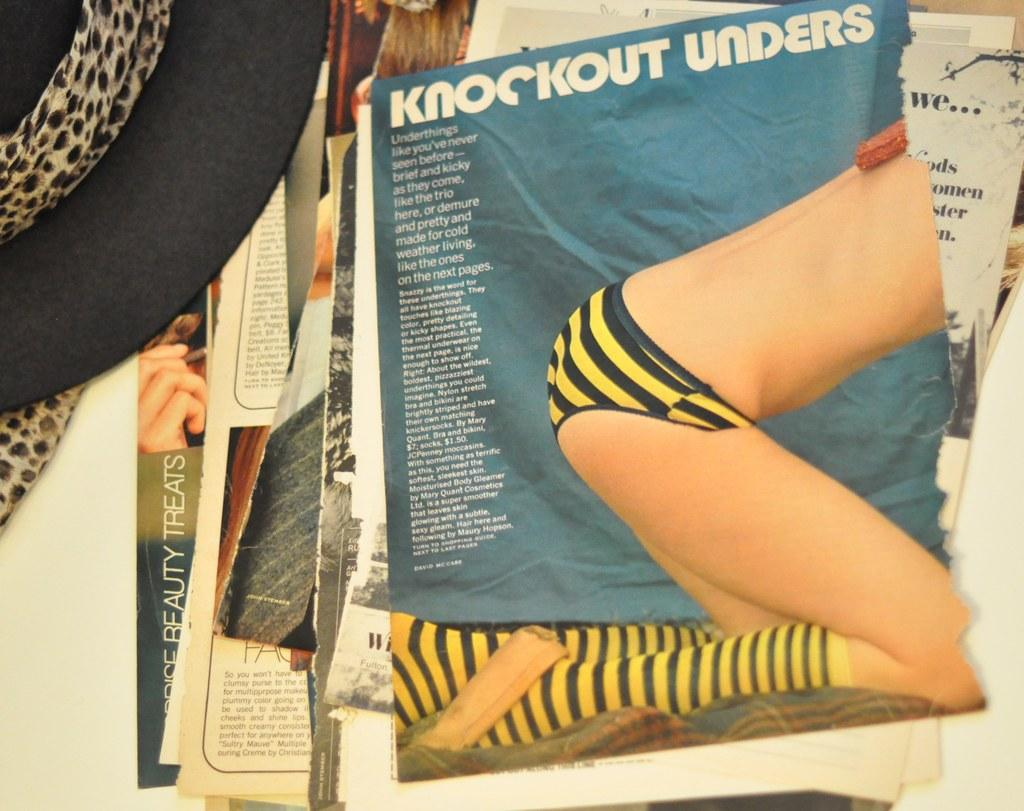<image>
Summarize the visual content of the image. The editorial Knockout Unders features a photograph of a woman in yellow and black striped bottoms. 